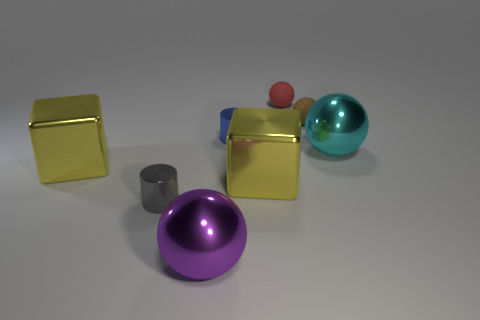Subtract all big purple spheres. How many spheres are left? 3 Add 1 brown rubber things. How many objects exist? 9 Subtract all purple balls. How many balls are left? 3 Subtract all cylinders. How many objects are left? 6 Add 2 big cyan metallic spheres. How many big cyan metallic spheres are left? 3 Add 7 big cyan things. How many big cyan things exist? 8 Subtract 0 gray cubes. How many objects are left? 8 Subtract 2 spheres. How many spheres are left? 2 Subtract all red blocks. Subtract all cyan balls. How many blocks are left? 2 Subtract all cyan cylinders. How many green blocks are left? 0 